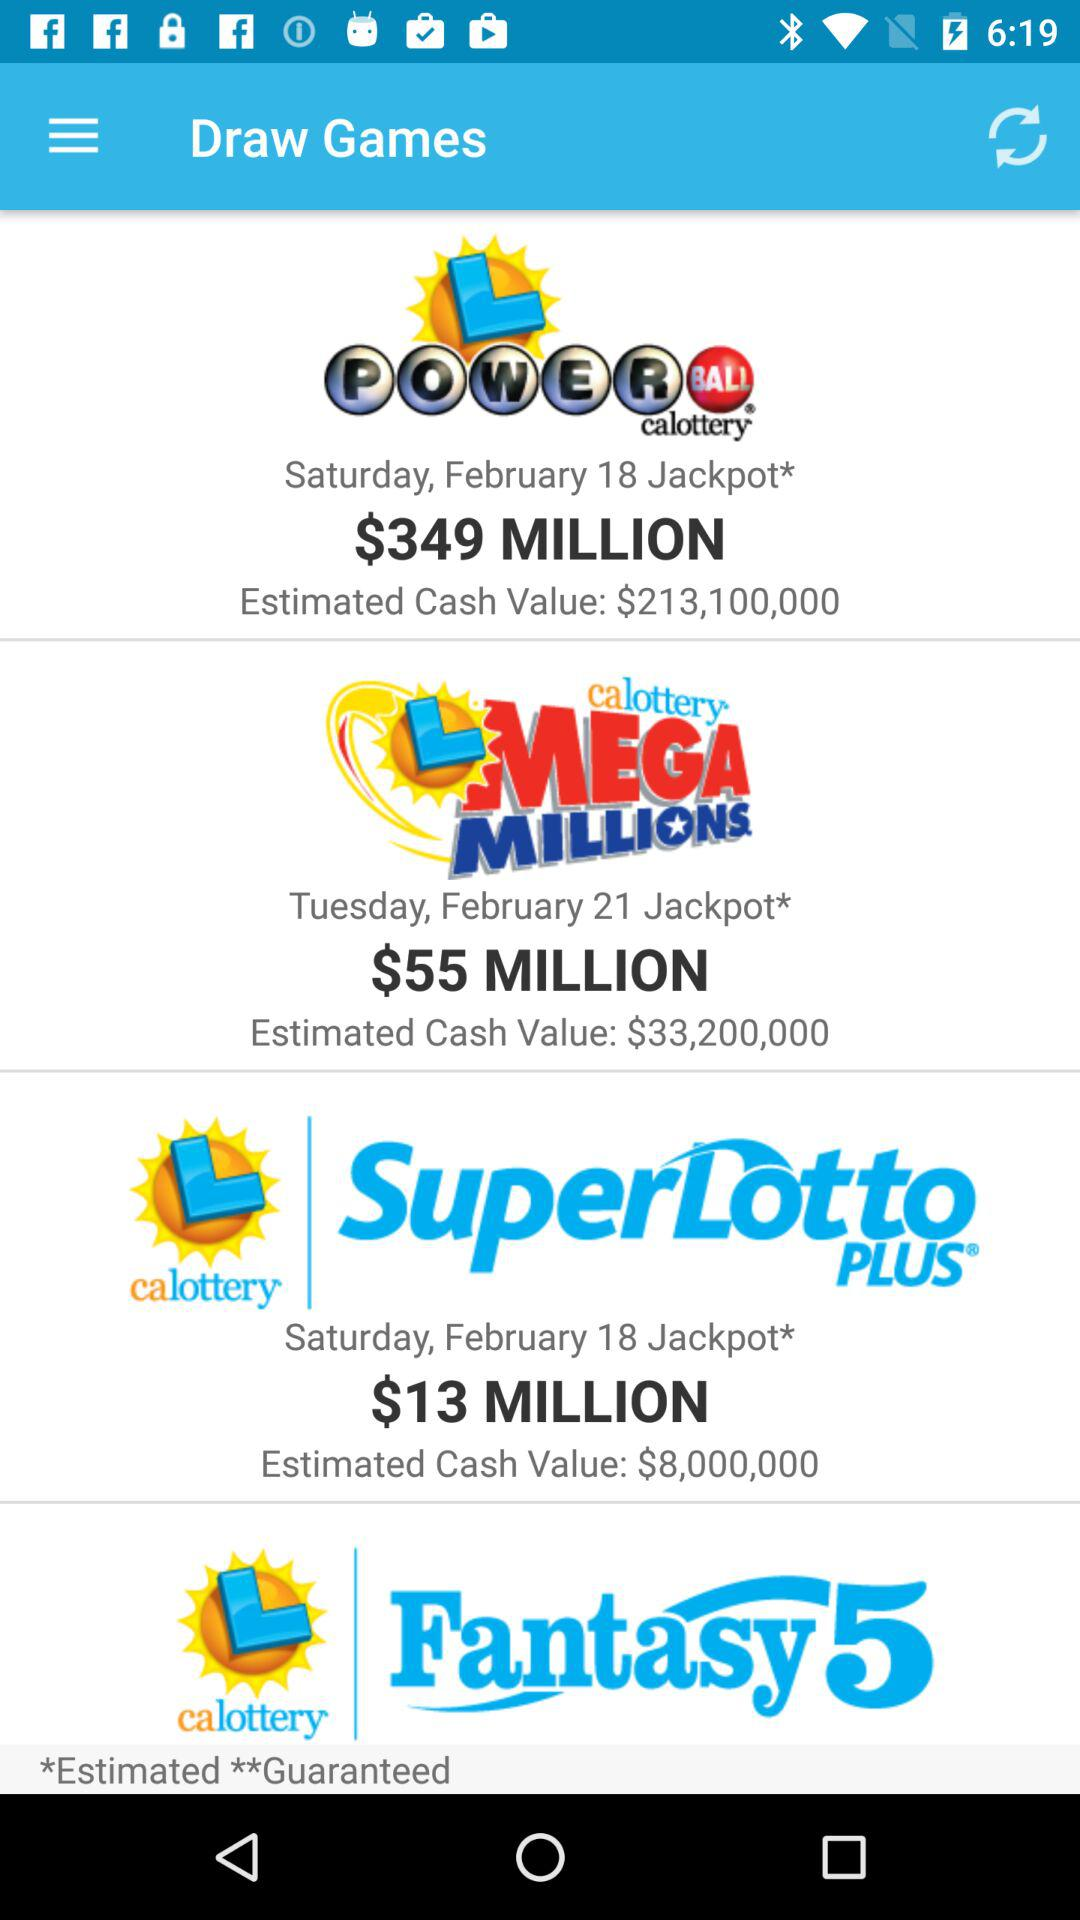What is the jackpot date of "L MEGA MILLIONS"? The jackpot date is Tuesday, 21 February. 